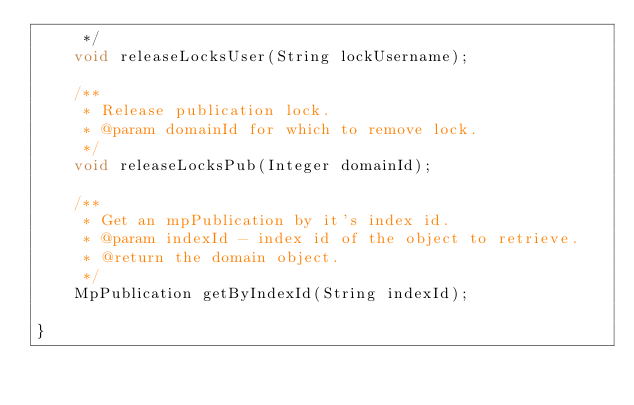Convert code to text. <code><loc_0><loc_0><loc_500><loc_500><_Java_>	 */
	void releaseLocksUser(String lockUsername);

	/**
	 * Release publication lock.
	 * @param domainId for which to remove lock.
	 */
	void releaseLocksPub(Integer domainId);

	/** 
	 * Get an mpPublication by it's index id.
	 * @param indexId - index id of the object to retrieve. 
	 * @return the domain object.
	 */
	MpPublication getByIndexId(String indexId);

}
</code> 